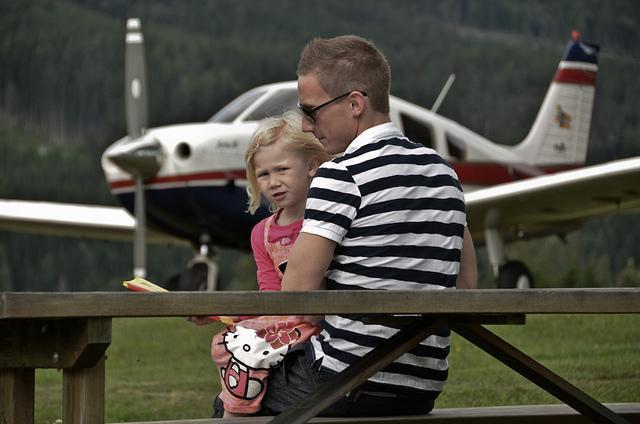How many people are there?
Give a very brief answer. 2. How many bikes are shown?
Give a very brief answer. 0. 